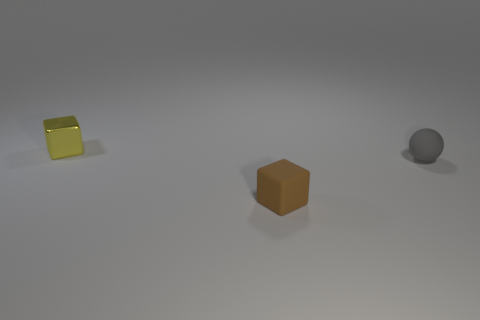Add 1 tiny matte blocks. How many objects exist? 4 Subtract all spheres. How many objects are left? 2 Add 3 red metal blocks. How many red metal blocks exist? 3 Subtract 0 red cylinders. How many objects are left? 3 Subtract all tiny green things. Subtract all gray rubber spheres. How many objects are left? 2 Add 2 yellow shiny things. How many yellow shiny things are left? 3 